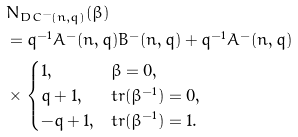<formula> <loc_0><loc_0><loc_500><loc_500>& N _ { D C ^ { - } ( n , q ) } ( \beta ) \\ & = q ^ { - 1 } A ^ { - } ( n , q ) B ^ { - } ( n , q ) + q ^ { - 1 } A ^ { - } ( n , q ) \\ & \times \begin{cases} 1 , & \beta = 0 , \\ q + 1 , & t r ( \beta ^ { - 1 } ) = 0 , \\ - q + 1 , & t r ( \beta ^ { - 1 } ) = 1 . \end{cases}</formula> 